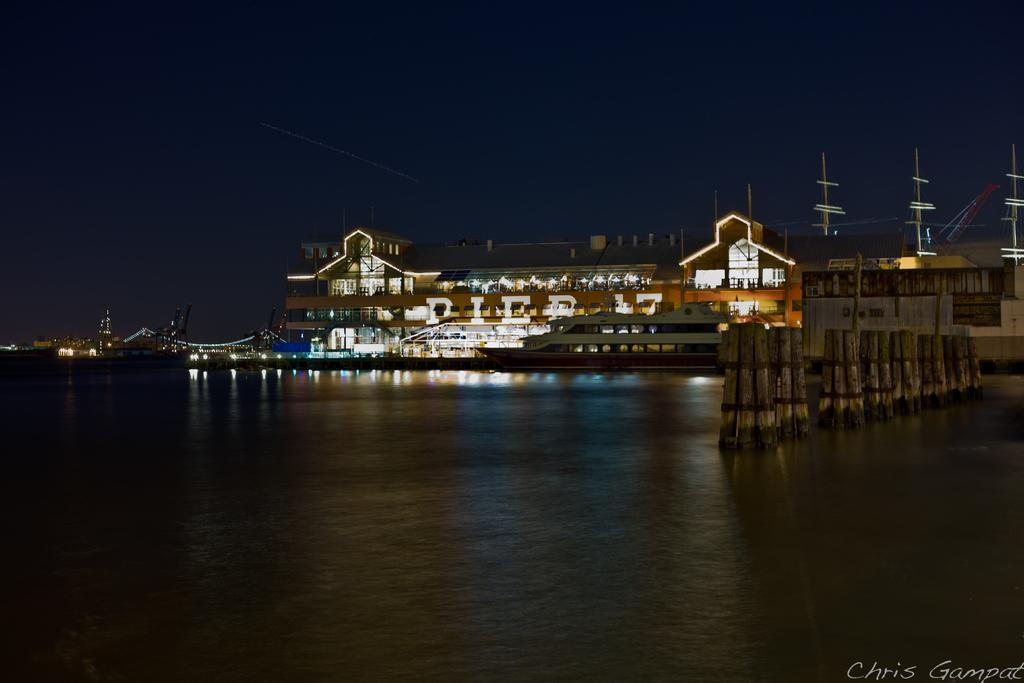What type of structures can be seen in the image? There are buildings in the image. What is located in the water in the image? There is a ship in the water. What connects the two sides in the image? There is a bridge in the image. What is providing illumination in the image? There is lighting in the image. What are the vertical supports in the image? There are poles in the image. What type of sweater is being worn by the ship in the image? There is no sweater present in the image, as it features a ship in the water. How many rolls can be seen on the bridge in the image? There are no rolls visible on the bridge in the image. 